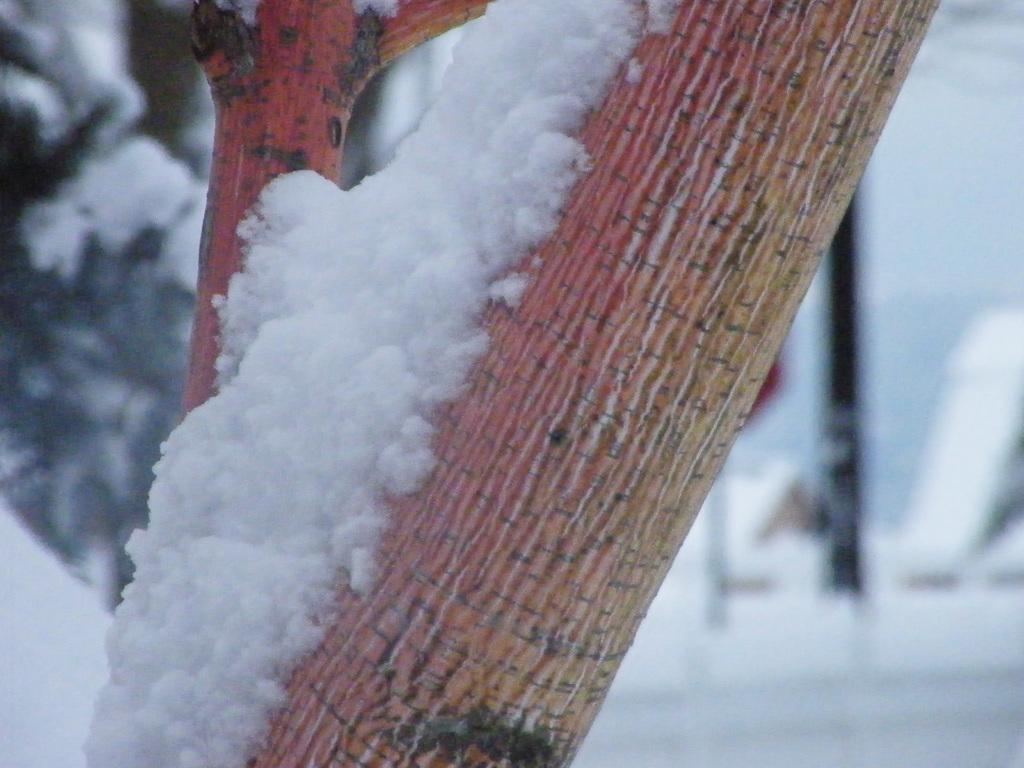What is covering the bark of the tree in the image? There is snow on the bark of a tree in the image. What other object can be seen in the image? There is a pole visible in the image. What type of natural element is present in the image? There is a tree in the image. What type of spark can be seen in the image? There is no spark present in the image. What type of clouds can be seen in the image? There is no mention of clouds in the provided facts, and therefore we cannot determine if clouds are present in the image. 